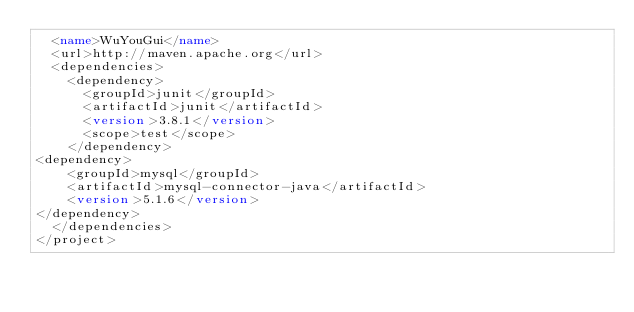<code> <loc_0><loc_0><loc_500><loc_500><_XML_>  <name>WuYouGui</name>
  <url>http://maven.apache.org</url>
  <dependencies>
    <dependency>
      <groupId>junit</groupId>
      <artifactId>junit</artifactId>
      <version>3.8.1</version>
      <scope>test</scope>
    </dependency>
<dependency>
    <groupId>mysql</groupId>
    <artifactId>mysql-connector-java</artifactId>
    <version>5.1.6</version>
</dependency>
  </dependencies>
</project>
</code> 